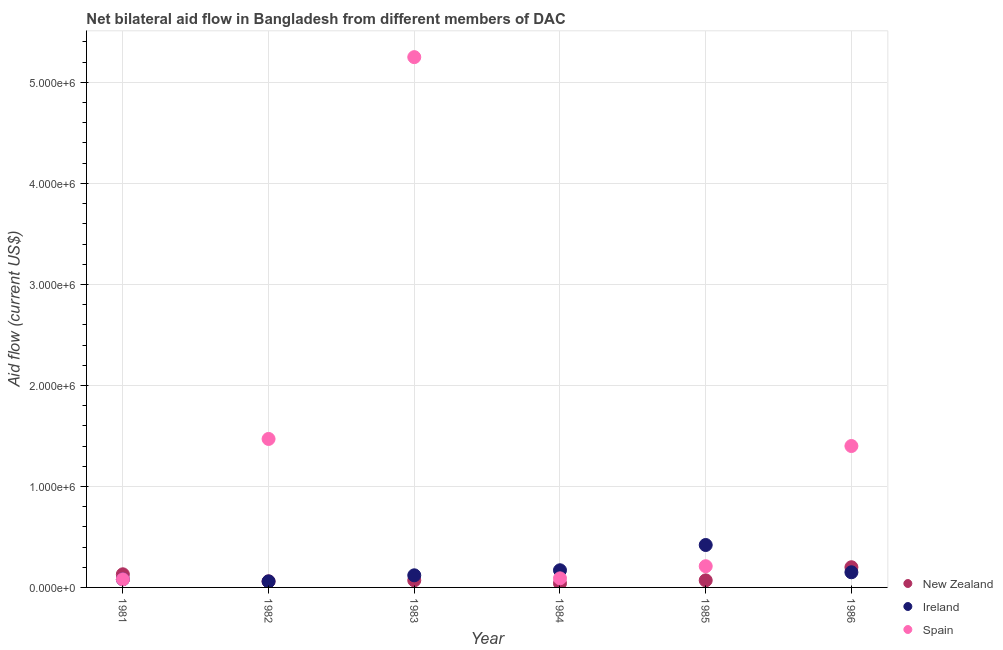How many different coloured dotlines are there?
Your answer should be very brief. 3. Is the number of dotlines equal to the number of legend labels?
Make the answer very short. Yes. What is the amount of aid provided by ireland in 1985?
Keep it short and to the point. 4.20e+05. Across all years, what is the maximum amount of aid provided by spain?
Keep it short and to the point. 5.25e+06. Across all years, what is the minimum amount of aid provided by ireland?
Ensure brevity in your answer.  6.00e+04. In which year was the amount of aid provided by ireland minimum?
Your response must be concise. 1982. What is the total amount of aid provided by spain in the graph?
Your answer should be very brief. 8.50e+06. What is the difference between the amount of aid provided by ireland in 1982 and that in 1983?
Your answer should be very brief. -6.00e+04. What is the difference between the amount of aid provided by ireland in 1985 and the amount of aid provided by new zealand in 1983?
Give a very brief answer. 3.50e+05. What is the average amount of aid provided by new zealand per year?
Your answer should be compact. 9.50e+04. In the year 1983, what is the difference between the amount of aid provided by spain and amount of aid provided by ireland?
Your answer should be compact. 5.13e+06. What is the ratio of the amount of aid provided by spain in 1984 to that in 1985?
Your response must be concise. 0.43. Is the difference between the amount of aid provided by ireland in 1981 and 1984 greater than the difference between the amount of aid provided by spain in 1981 and 1984?
Offer a terse response. No. What is the difference between the highest and the second highest amount of aid provided by new zealand?
Keep it short and to the point. 7.00e+04. What is the difference between the highest and the lowest amount of aid provided by new zealand?
Your answer should be compact. 1.60e+05. In how many years, is the amount of aid provided by new zealand greater than the average amount of aid provided by new zealand taken over all years?
Give a very brief answer. 2. Does the amount of aid provided by spain monotonically increase over the years?
Your answer should be compact. No. Is the amount of aid provided by ireland strictly greater than the amount of aid provided by spain over the years?
Provide a succinct answer. No. How many dotlines are there?
Keep it short and to the point. 3. What is the difference between two consecutive major ticks on the Y-axis?
Provide a succinct answer. 1.00e+06. Are the values on the major ticks of Y-axis written in scientific E-notation?
Your answer should be very brief. Yes. Does the graph contain any zero values?
Give a very brief answer. No. Does the graph contain grids?
Your response must be concise. Yes. Where does the legend appear in the graph?
Your answer should be very brief. Bottom right. How many legend labels are there?
Give a very brief answer. 3. How are the legend labels stacked?
Your answer should be compact. Vertical. What is the title of the graph?
Your response must be concise. Net bilateral aid flow in Bangladesh from different members of DAC. Does "Taxes on goods and services" appear as one of the legend labels in the graph?
Provide a succinct answer. No. What is the label or title of the X-axis?
Offer a terse response. Year. What is the Aid flow (current US$) in Spain in 1981?
Your answer should be compact. 8.00e+04. What is the Aid flow (current US$) in Spain in 1982?
Your answer should be very brief. 1.47e+06. What is the Aid flow (current US$) in New Zealand in 1983?
Offer a very short reply. 7.00e+04. What is the Aid flow (current US$) of Spain in 1983?
Provide a succinct answer. 5.25e+06. What is the Aid flow (current US$) in Spain in 1984?
Your response must be concise. 9.00e+04. What is the Aid flow (current US$) in New Zealand in 1985?
Keep it short and to the point. 7.00e+04. What is the Aid flow (current US$) of Ireland in 1985?
Provide a short and direct response. 4.20e+05. What is the Aid flow (current US$) of Spain in 1985?
Ensure brevity in your answer.  2.10e+05. What is the Aid flow (current US$) in New Zealand in 1986?
Your response must be concise. 2.00e+05. What is the Aid flow (current US$) in Ireland in 1986?
Keep it short and to the point. 1.50e+05. What is the Aid flow (current US$) of Spain in 1986?
Ensure brevity in your answer.  1.40e+06. Across all years, what is the maximum Aid flow (current US$) in New Zealand?
Keep it short and to the point. 2.00e+05. Across all years, what is the maximum Aid flow (current US$) of Spain?
Provide a short and direct response. 5.25e+06. Across all years, what is the minimum Aid flow (current US$) of Ireland?
Provide a short and direct response. 6.00e+04. Across all years, what is the minimum Aid flow (current US$) of Spain?
Offer a terse response. 8.00e+04. What is the total Aid flow (current US$) in New Zealand in the graph?
Make the answer very short. 5.70e+05. What is the total Aid flow (current US$) of Spain in the graph?
Provide a short and direct response. 8.50e+06. What is the difference between the Aid flow (current US$) of New Zealand in 1981 and that in 1982?
Provide a succinct answer. 7.00e+04. What is the difference between the Aid flow (current US$) in Ireland in 1981 and that in 1982?
Offer a terse response. 2.00e+04. What is the difference between the Aid flow (current US$) in Spain in 1981 and that in 1982?
Give a very brief answer. -1.39e+06. What is the difference between the Aid flow (current US$) in Ireland in 1981 and that in 1983?
Your answer should be very brief. -4.00e+04. What is the difference between the Aid flow (current US$) in Spain in 1981 and that in 1983?
Keep it short and to the point. -5.17e+06. What is the difference between the Aid flow (current US$) of New Zealand in 1981 and that in 1984?
Make the answer very short. 9.00e+04. What is the difference between the Aid flow (current US$) of Spain in 1981 and that in 1984?
Your answer should be compact. -10000. What is the difference between the Aid flow (current US$) in Ireland in 1981 and that in 1985?
Provide a short and direct response. -3.40e+05. What is the difference between the Aid flow (current US$) of Spain in 1981 and that in 1985?
Make the answer very short. -1.30e+05. What is the difference between the Aid flow (current US$) of New Zealand in 1981 and that in 1986?
Keep it short and to the point. -7.00e+04. What is the difference between the Aid flow (current US$) of Spain in 1981 and that in 1986?
Give a very brief answer. -1.32e+06. What is the difference between the Aid flow (current US$) in Ireland in 1982 and that in 1983?
Keep it short and to the point. -6.00e+04. What is the difference between the Aid flow (current US$) of Spain in 1982 and that in 1983?
Provide a short and direct response. -3.78e+06. What is the difference between the Aid flow (current US$) in Spain in 1982 and that in 1984?
Give a very brief answer. 1.38e+06. What is the difference between the Aid flow (current US$) in New Zealand in 1982 and that in 1985?
Offer a terse response. -10000. What is the difference between the Aid flow (current US$) of Ireland in 1982 and that in 1985?
Offer a terse response. -3.60e+05. What is the difference between the Aid flow (current US$) in Spain in 1982 and that in 1985?
Your response must be concise. 1.26e+06. What is the difference between the Aid flow (current US$) in Ireland in 1982 and that in 1986?
Provide a succinct answer. -9.00e+04. What is the difference between the Aid flow (current US$) in Spain in 1982 and that in 1986?
Offer a terse response. 7.00e+04. What is the difference between the Aid flow (current US$) in Spain in 1983 and that in 1984?
Provide a succinct answer. 5.16e+06. What is the difference between the Aid flow (current US$) in New Zealand in 1983 and that in 1985?
Keep it short and to the point. 0. What is the difference between the Aid flow (current US$) in Ireland in 1983 and that in 1985?
Offer a very short reply. -3.00e+05. What is the difference between the Aid flow (current US$) of Spain in 1983 and that in 1985?
Your answer should be compact. 5.04e+06. What is the difference between the Aid flow (current US$) of Ireland in 1983 and that in 1986?
Make the answer very short. -3.00e+04. What is the difference between the Aid flow (current US$) of Spain in 1983 and that in 1986?
Provide a succinct answer. 3.85e+06. What is the difference between the Aid flow (current US$) in New Zealand in 1984 and that in 1985?
Offer a terse response. -3.00e+04. What is the difference between the Aid flow (current US$) in Ireland in 1984 and that in 1985?
Your answer should be very brief. -2.50e+05. What is the difference between the Aid flow (current US$) of New Zealand in 1984 and that in 1986?
Keep it short and to the point. -1.60e+05. What is the difference between the Aid flow (current US$) in Ireland in 1984 and that in 1986?
Provide a succinct answer. 2.00e+04. What is the difference between the Aid flow (current US$) in Spain in 1984 and that in 1986?
Provide a short and direct response. -1.31e+06. What is the difference between the Aid flow (current US$) in Spain in 1985 and that in 1986?
Your answer should be compact. -1.19e+06. What is the difference between the Aid flow (current US$) of New Zealand in 1981 and the Aid flow (current US$) of Ireland in 1982?
Your answer should be very brief. 7.00e+04. What is the difference between the Aid flow (current US$) of New Zealand in 1981 and the Aid flow (current US$) of Spain in 1982?
Offer a very short reply. -1.34e+06. What is the difference between the Aid flow (current US$) of Ireland in 1981 and the Aid flow (current US$) of Spain in 1982?
Give a very brief answer. -1.39e+06. What is the difference between the Aid flow (current US$) of New Zealand in 1981 and the Aid flow (current US$) of Ireland in 1983?
Your response must be concise. 10000. What is the difference between the Aid flow (current US$) of New Zealand in 1981 and the Aid flow (current US$) of Spain in 1983?
Your answer should be very brief. -5.12e+06. What is the difference between the Aid flow (current US$) in Ireland in 1981 and the Aid flow (current US$) in Spain in 1983?
Offer a very short reply. -5.17e+06. What is the difference between the Aid flow (current US$) in New Zealand in 1981 and the Aid flow (current US$) in Ireland in 1984?
Make the answer very short. -4.00e+04. What is the difference between the Aid flow (current US$) in Ireland in 1981 and the Aid flow (current US$) in Spain in 1984?
Your answer should be very brief. -10000. What is the difference between the Aid flow (current US$) in New Zealand in 1981 and the Aid flow (current US$) in Ireland in 1985?
Offer a terse response. -2.90e+05. What is the difference between the Aid flow (current US$) in New Zealand in 1981 and the Aid flow (current US$) in Spain in 1985?
Your response must be concise. -8.00e+04. What is the difference between the Aid flow (current US$) of New Zealand in 1981 and the Aid flow (current US$) of Spain in 1986?
Ensure brevity in your answer.  -1.27e+06. What is the difference between the Aid flow (current US$) in Ireland in 1981 and the Aid flow (current US$) in Spain in 1986?
Offer a terse response. -1.32e+06. What is the difference between the Aid flow (current US$) in New Zealand in 1982 and the Aid flow (current US$) in Spain in 1983?
Offer a very short reply. -5.19e+06. What is the difference between the Aid flow (current US$) in Ireland in 1982 and the Aid flow (current US$) in Spain in 1983?
Offer a terse response. -5.19e+06. What is the difference between the Aid flow (current US$) in Ireland in 1982 and the Aid flow (current US$) in Spain in 1984?
Ensure brevity in your answer.  -3.00e+04. What is the difference between the Aid flow (current US$) of New Zealand in 1982 and the Aid flow (current US$) of Ireland in 1985?
Give a very brief answer. -3.60e+05. What is the difference between the Aid flow (current US$) of Ireland in 1982 and the Aid flow (current US$) of Spain in 1985?
Make the answer very short. -1.50e+05. What is the difference between the Aid flow (current US$) in New Zealand in 1982 and the Aid flow (current US$) in Ireland in 1986?
Keep it short and to the point. -9.00e+04. What is the difference between the Aid flow (current US$) in New Zealand in 1982 and the Aid flow (current US$) in Spain in 1986?
Offer a very short reply. -1.34e+06. What is the difference between the Aid flow (current US$) in Ireland in 1982 and the Aid flow (current US$) in Spain in 1986?
Provide a succinct answer. -1.34e+06. What is the difference between the Aid flow (current US$) in New Zealand in 1983 and the Aid flow (current US$) in Spain in 1984?
Your answer should be very brief. -2.00e+04. What is the difference between the Aid flow (current US$) of New Zealand in 1983 and the Aid flow (current US$) of Ireland in 1985?
Keep it short and to the point. -3.50e+05. What is the difference between the Aid flow (current US$) in Ireland in 1983 and the Aid flow (current US$) in Spain in 1985?
Your answer should be very brief. -9.00e+04. What is the difference between the Aid flow (current US$) in New Zealand in 1983 and the Aid flow (current US$) in Ireland in 1986?
Offer a very short reply. -8.00e+04. What is the difference between the Aid flow (current US$) in New Zealand in 1983 and the Aid flow (current US$) in Spain in 1986?
Your answer should be compact. -1.33e+06. What is the difference between the Aid flow (current US$) in Ireland in 1983 and the Aid flow (current US$) in Spain in 1986?
Ensure brevity in your answer.  -1.28e+06. What is the difference between the Aid flow (current US$) of New Zealand in 1984 and the Aid flow (current US$) of Ireland in 1985?
Your answer should be very brief. -3.80e+05. What is the difference between the Aid flow (current US$) in New Zealand in 1984 and the Aid flow (current US$) in Spain in 1985?
Your answer should be very brief. -1.70e+05. What is the difference between the Aid flow (current US$) of New Zealand in 1984 and the Aid flow (current US$) of Spain in 1986?
Your answer should be very brief. -1.36e+06. What is the difference between the Aid flow (current US$) in Ireland in 1984 and the Aid flow (current US$) in Spain in 1986?
Your answer should be very brief. -1.23e+06. What is the difference between the Aid flow (current US$) in New Zealand in 1985 and the Aid flow (current US$) in Ireland in 1986?
Your answer should be compact. -8.00e+04. What is the difference between the Aid flow (current US$) in New Zealand in 1985 and the Aid flow (current US$) in Spain in 1986?
Your answer should be very brief. -1.33e+06. What is the difference between the Aid flow (current US$) of Ireland in 1985 and the Aid flow (current US$) of Spain in 1986?
Offer a very short reply. -9.80e+05. What is the average Aid flow (current US$) in New Zealand per year?
Ensure brevity in your answer.  9.50e+04. What is the average Aid flow (current US$) of Ireland per year?
Make the answer very short. 1.67e+05. What is the average Aid flow (current US$) of Spain per year?
Offer a terse response. 1.42e+06. In the year 1981, what is the difference between the Aid flow (current US$) in New Zealand and Aid flow (current US$) in Ireland?
Provide a short and direct response. 5.00e+04. In the year 1981, what is the difference between the Aid flow (current US$) in Ireland and Aid flow (current US$) in Spain?
Ensure brevity in your answer.  0. In the year 1982, what is the difference between the Aid flow (current US$) of New Zealand and Aid flow (current US$) of Ireland?
Ensure brevity in your answer.  0. In the year 1982, what is the difference between the Aid flow (current US$) in New Zealand and Aid flow (current US$) in Spain?
Give a very brief answer. -1.41e+06. In the year 1982, what is the difference between the Aid flow (current US$) in Ireland and Aid flow (current US$) in Spain?
Offer a very short reply. -1.41e+06. In the year 1983, what is the difference between the Aid flow (current US$) in New Zealand and Aid flow (current US$) in Spain?
Your response must be concise. -5.18e+06. In the year 1983, what is the difference between the Aid flow (current US$) of Ireland and Aid flow (current US$) of Spain?
Your answer should be very brief. -5.13e+06. In the year 1984, what is the difference between the Aid flow (current US$) of New Zealand and Aid flow (current US$) of Spain?
Make the answer very short. -5.00e+04. In the year 1984, what is the difference between the Aid flow (current US$) in Ireland and Aid flow (current US$) in Spain?
Your response must be concise. 8.00e+04. In the year 1985, what is the difference between the Aid flow (current US$) in New Zealand and Aid flow (current US$) in Ireland?
Keep it short and to the point. -3.50e+05. In the year 1986, what is the difference between the Aid flow (current US$) in New Zealand and Aid flow (current US$) in Spain?
Make the answer very short. -1.20e+06. In the year 1986, what is the difference between the Aid flow (current US$) of Ireland and Aid flow (current US$) of Spain?
Offer a terse response. -1.25e+06. What is the ratio of the Aid flow (current US$) of New Zealand in 1981 to that in 1982?
Offer a very short reply. 2.17. What is the ratio of the Aid flow (current US$) in Ireland in 1981 to that in 1982?
Your answer should be very brief. 1.33. What is the ratio of the Aid flow (current US$) of Spain in 1981 to that in 1982?
Ensure brevity in your answer.  0.05. What is the ratio of the Aid flow (current US$) of New Zealand in 1981 to that in 1983?
Keep it short and to the point. 1.86. What is the ratio of the Aid flow (current US$) of Ireland in 1981 to that in 1983?
Your answer should be very brief. 0.67. What is the ratio of the Aid flow (current US$) in Spain in 1981 to that in 1983?
Your response must be concise. 0.02. What is the ratio of the Aid flow (current US$) in New Zealand in 1981 to that in 1984?
Give a very brief answer. 3.25. What is the ratio of the Aid flow (current US$) in Ireland in 1981 to that in 1984?
Provide a succinct answer. 0.47. What is the ratio of the Aid flow (current US$) of New Zealand in 1981 to that in 1985?
Make the answer very short. 1.86. What is the ratio of the Aid flow (current US$) of Ireland in 1981 to that in 1985?
Give a very brief answer. 0.19. What is the ratio of the Aid flow (current US$) in Spain in 1981 to that in 1985?
Your answer should be compact. 0.38. What is the ratio of the Aid flow (current US$) of New Zealand in 1981 to that in 1986?
Give a very brief answer. 0.65. What is the ratio of the Aid flow (current US$) of Ireland in 1981 to that in 1986?
Keep it short and to the point. 0.53. What is the ratio of the Aid flow (current US$) of Spain in 1981 to that in 1986?
Provide a short and direct response. 0.06. What is the ratio of the Aid flow (current US$) of Ireland in 1982 to that in 1983?
Offer a terse response. 0.5. What is the ratio of the Aid flow (current US$) in Spain in 1982 to that in 1983?
Your response must be concise. 0.28. What is the ratio of the Aid flow (current US$) of Ireland in 1982 to that in 1984?
Give a very brief answer. 0.35. What is the ratio of the Aid flow (current US$) of Spain in 1982 to that in 1984?
Ensure brevity in your answer.  16.33. What is the ratio of the Aid flow (current US$) in Ireland in 1982 to that in 1985?
Give a very brief answer. 0.14. What is the ratio of the Aid flow (current US$) of Spain in 1982 to that in 1985?
Give a very brief answer. 7. What is the ratio of the Aid flow (current US$) of Ireland in 1982 to that in 1986?
Keep it short and to the point. 0.4. What is the ratio of the Aid flow (current US$) of Spain in 1982 to that in 1986?
Provide a short and direct response. 1.05. What is the ratio of the Aid flow (current US$) of New Zealand in 1983 to that in 1984?
Your response must be concise. 1.75. What is the ratio of the Aid flow (current US$) of Ireland in 1983 to that in 1984?
Your answer should be compact. 0.71. What is the ratio of the Aid flow (current US$) of Spain in 1983 to that in 1984?
Make the answer very short. 58.33. What is the ratio of the Aid flow (current US$) in Ireland in 1983 to that in 1985?
Your response must be concise. 0.29. What is the ratio of the Aid flow (current US$) in New Zealand in 1983 to that in 1986?
Make the answer very short. 0.35. What is the ratio of the Aid flow (current US$) in Ireland in 1983 to that in 1986?
Provide a succinct answer. 0.8. What is the ratio of the Aid flow (current US$) in Spain in 1983 to that in 1986?
Provide a short and direct response. 3.75. What is the ratio of the Aid flow (current US$) of Ireland in 1984 to that in 1985?
Keep it short and to the point. 0.4. What is the ratio of the Aid flow (current US$) of Spain in 1984 to that in 1985?
Offer a terse response. 0.43. What is the ratio of the Aid flow (current US$) of Ireland in 1984 to that in 1986?
Offer a very short reply. 1.13. What is the ratio of the Aid flow (current US$) in Spain in 1984 to that in 1986?
Provide a short and direct response. 0.06. What is the difference between the highest and the second highest Aid flow (current US$) in Ireland?
Ensure brevity in your answer.  2.50e+05. What is the difference between the highest and the second highest Aid flow (current US$) in Spain?
Your response must be concise. 3.78e+06. What is the difference between the highest and the lowest Aid flow (current US$) in Spain?
Provide a succinct answer. 5.17e+06. 